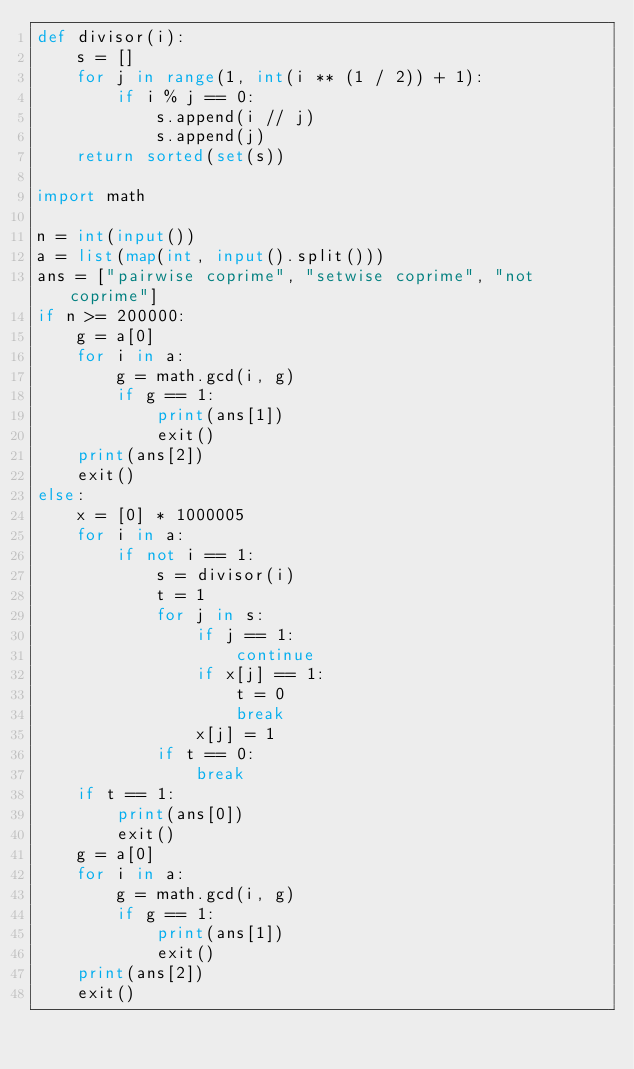<code> <loc_0><loc_0><loc_500><loc_500><_Python_>def divisor(i):
    s = []
    for j in range(1, int(i ** (1 / 2)) + 1):
        if i % j == 0:
            s.append(i // j)
            s.append(j)
    return sorted(set(s))

import math

n = int(input())
a = list(map(int, input().split()))
ans = ["pairwise coprime", "setwise coprime", "not coprime"]
if n >= 200000:
    g = a[0]
    for i in a:
        g = math.gcd(i, g)
        if g == 1:
            print(ans[1])
            exit()
    print(ans[2])
    exit()
else:
    x = [0] * 1000005
    for i in a:
        if not i == 1:
            s = divisor(i)
            t = 1
            for j in s:
                if j == 1:
                    continue
                if x[j] == 1:
                    t = 0
                    break
                x[j] = 1
            if t == 0:
                break
    if t == 1:
        print(ans[0])
        exit()
    g = a[0]
    for i in a:
        g = math.gcd(i, g)
        if g == 1:
            print(ans[1])
            exit()
    print(ans[2])
    exit()</code> 